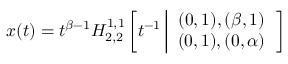Convert formula to latex. <formula><loc_0><loc_0><loc_500><loc_500>x ( t ) = t ^ { \beta - 1 } H _ { 2 , 2 } ^ { 1 , 1 } \left [ t ^ { - 1 } \left | \begin{array} { c } { ( 0 , 1 ) , ( \beta , 1 ) } \\ { ( 0 , 1 ) , ( 0 , \alpha ) } \end{array} \right ]</formula> 